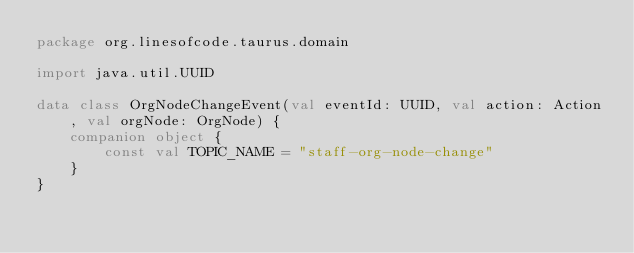<code> <loc_0><loc_0><loc_500><loc_500><_Kotlin_>package org.linesofcode.taurus.domain

import java.util.UUID

data class OrgNodeChangeEvent(val eventId: UUID, val action: Action, val orgNode: OrgNode) {
    companion object {
        const val TOPIC_NAME = "staff-org-node-change"
    }
}</code> 